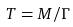<formula> <loc_0><loc_0><loc_500><loc_500>T = M / \Gamma</formula> 